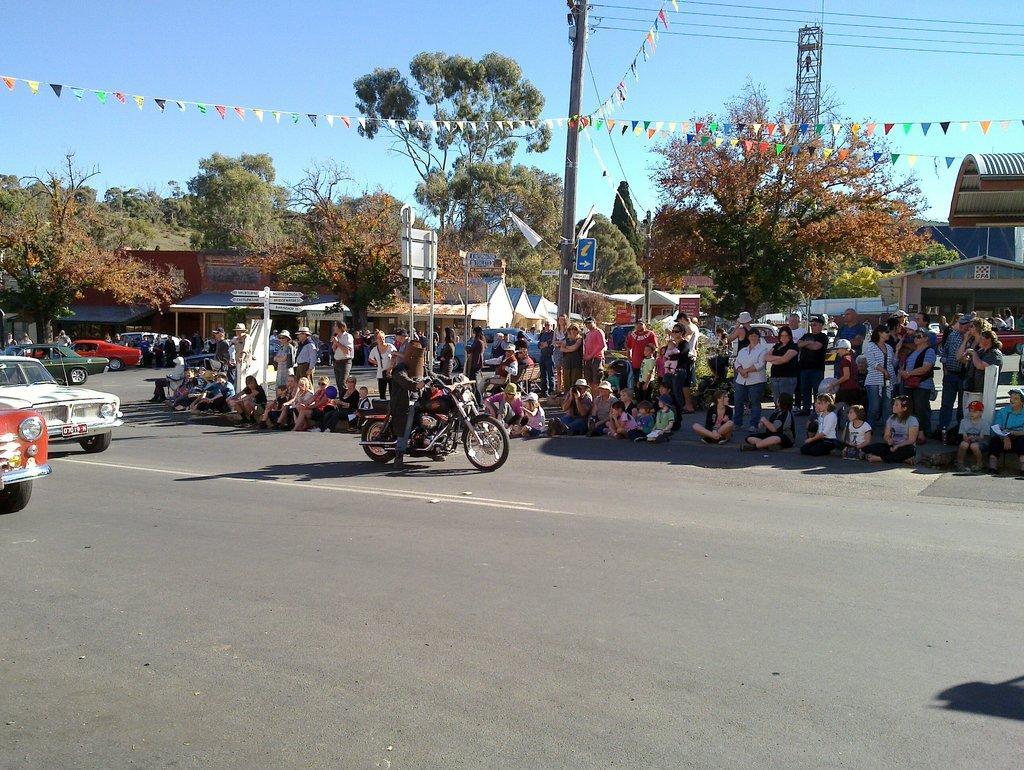Could you give a brief overview of what you see in this image? In this picture we can observe two cars on the road. We can observe a bike and a person on the bike here. There are children sitting on the road. We can observe some people standing and sitting on the road. In the background there are buildings, trees and a pole. We can observe a sky here. 